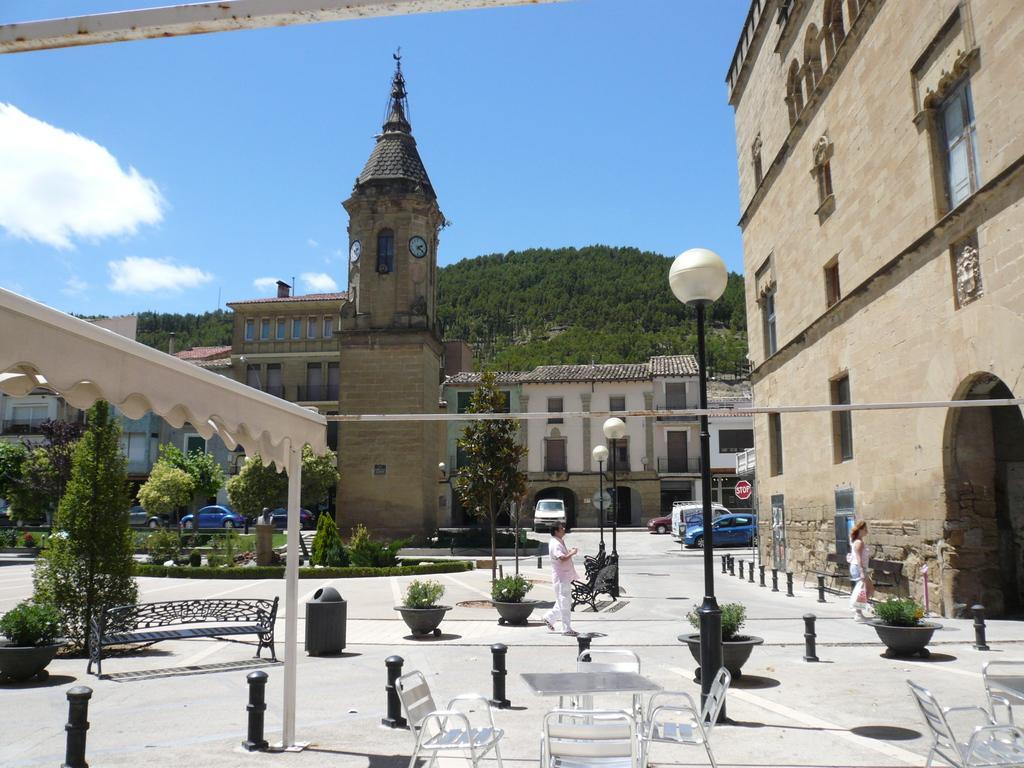Please provide a concise description of this image. On the right side there is a building with windows and arch. Near to that there is a lady. Also there are small poles, pots with plants, tables, chairs, street light poles. In the background there are trees, buildings and sky with clouds. Also there are vehicles. 